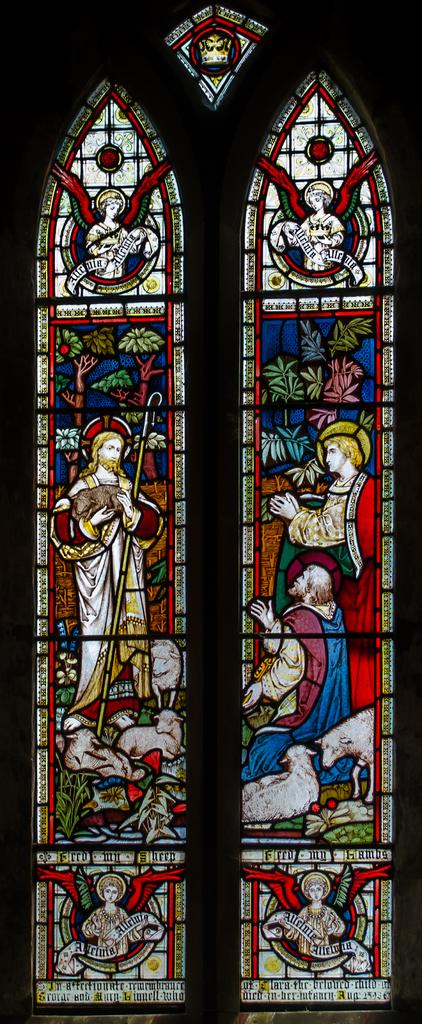What type of material is the main object in the image made of? The main object in the image is a glass window. Are there any decorations or additions on the glass window? Yes, there are stickers on the glass window. How many pies are being served by the monkey in the image? There is no monkey or pies present in the image; it only features a glass window with stickers on it. 